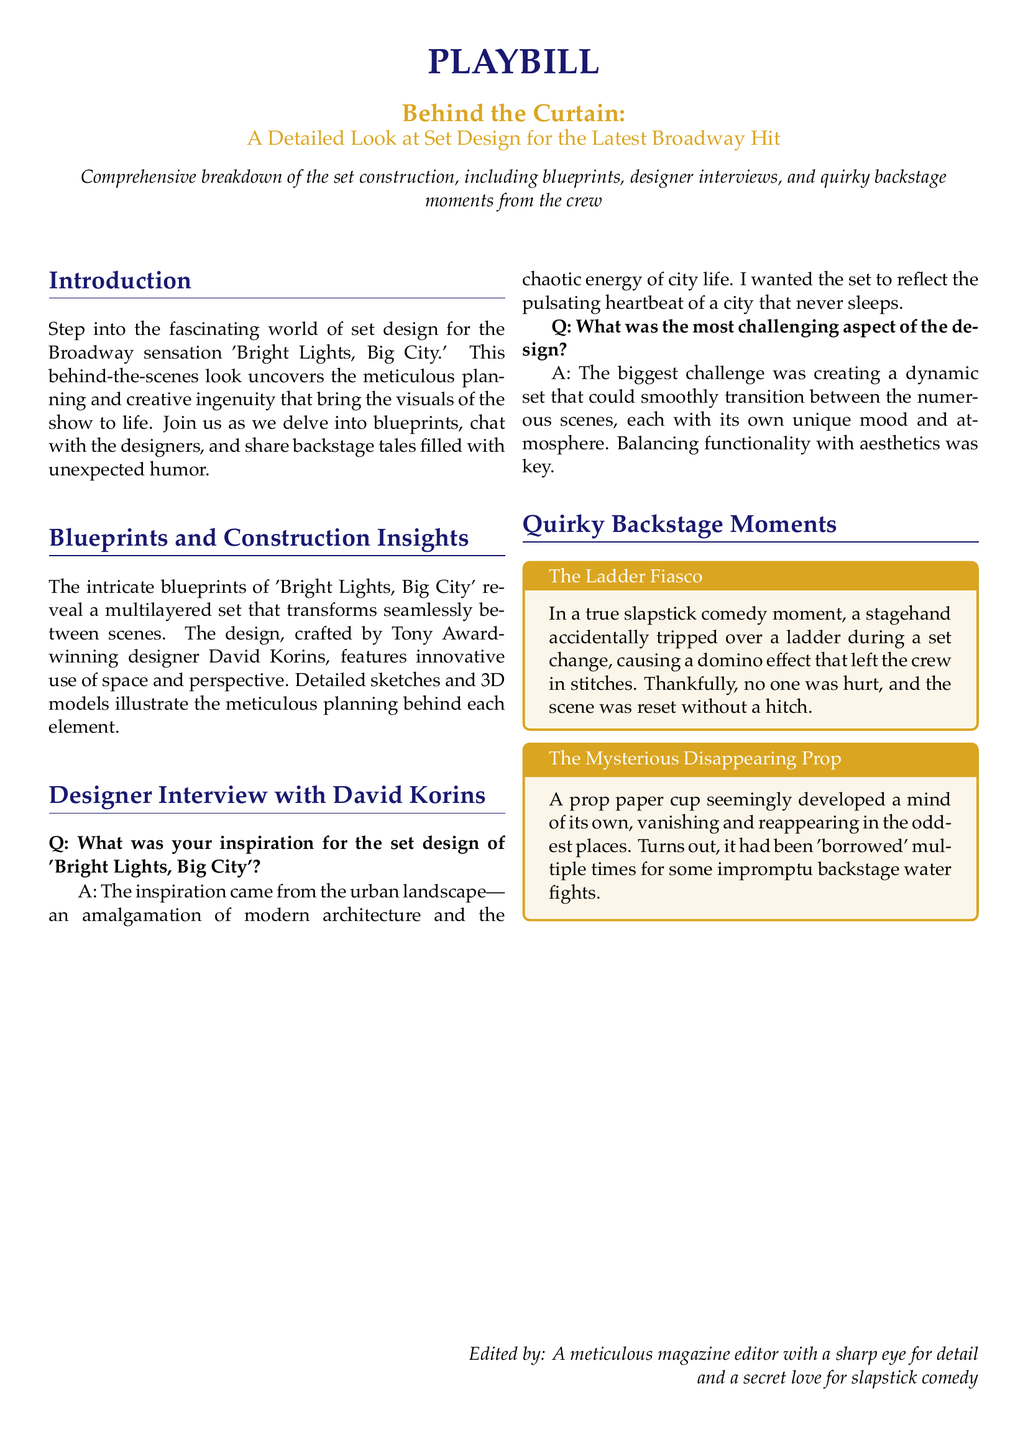What is the title of the Broadway hit discussed? The title of the Broadway hit is 'Bright Lights, Big City'.
Answer: 'Bright Lights, Big City' Who is the Tony Award-winning designer of the set? The designer of the set is David Korins.
Answer: David Korins What color is the playbill title text? The playbill title text is in gold color.
Answer: gold What does the document feature in addition to blueprints? The document features designer interviews.
Answer: designer interviews Which backstage moment is referred to as "The Ladder Fiasco"? "The Ladder Fiasco" is a moment when a stagehand tripped over a ladder.
Answer: a stagehand tripped over a ladder What two elements characterized the set design according to David Korins? The set design is characterized by modern architecture and chaotic energy.
Answer: modern architecture and chaotic energy What is the primary focus of the document? The primary focus of the document is a detailed look at set design.
Answer: set design What humorous prop is mentioned in the backstage moments? The humorous prop mentioned is a paper cup.
Answer: paper cup 